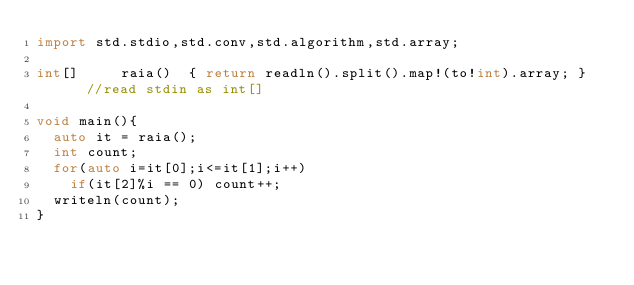<code> <loc_0><loc_0><loc_500><loc_500><_D_>import std.stdio,std.conv,std.algorithm,std.array;

int[] 		raia()	{ return readln().split().map!(to!int).array; }		//read stdin as int[]

void main(){
	auto it = raia();
	int count;
	for(auto i=it[0];i<=it[1];i++)
		if(it[2]%i == 0) count++;
	writeln(count);
}</code> 